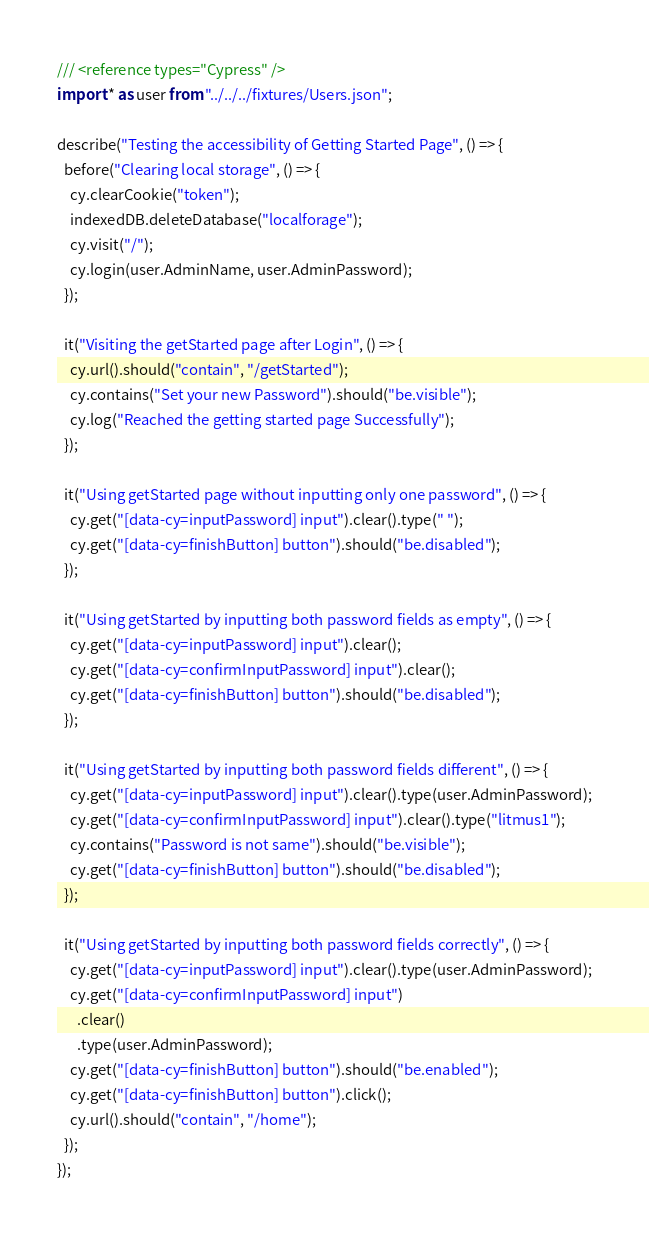Convert code to text. <code><loc_0><loc_0><loc_500><loc_500><_JavaScript_>/// <reference types="Cypress" />
import * as user from "../../../fixtures/Users.json";

describe("Testing the accessibility of Getting Started Page", () => {
  before("Clearing local storage", () => {
    cy.clearCookie("token");
    indexedDB.deleteDatabase("localforage");
    cy.visit("/");
    cy.login(user.AdminName, user.AdminPassword);
  });

  it("Visiting the getStarted page after Login", () => {
    cy.url().should("contain", "/getStarted");
    cy.contains("Set your new Password").should("be.visible");
    cy.log("Reached the getting started page Successfully");
  });

  it("Using getStarted page without inputting only one password", () => {
    cy.get("[data-cy=inputPassword] input").clear().type(" ");
    cy.get("[data-cy=finishButton] button").should("be.disabled");
  });

  it("Using getStarted by inputting both password fields as empty", () => {
    cy.get("[data-cy=inputPassword] input").clear();
    cy.get("[data-cy=confirmInputPassword] input").clear();
    cy.get("[data-cy=finishButton] button").should("be.disabled");
  });

  it("Using getStarted by inputting both password fields different", () => {
    cy.get("[data-cy=inputPassword] input").clear().type(user.AdminPassword);
    cy.get("[data-cy=confirmInputPassword] input").clear().type("litmus1");
    cy.contains("Password is not same").should("be.visible");
    cy.get("[data-cy=finishButton] button").should("be.disabled");
  });

  it("Using getStarted by inputting both password fields correctly", () => {
    cy.get("[data-cy=inputPassword] input").clear().type(user.AdminPassword);
    cy.get("[data-cy=confirmInputPassword] input")
      .clear()
      .type(user.AdminPassword);
    cy.get("[data-cy=finishButton] button").should("be.enabled");
    cy.get("[data-cy=finishButton] button").click();
    cy.url().should("contain", "/home");
  });
});
</code> 